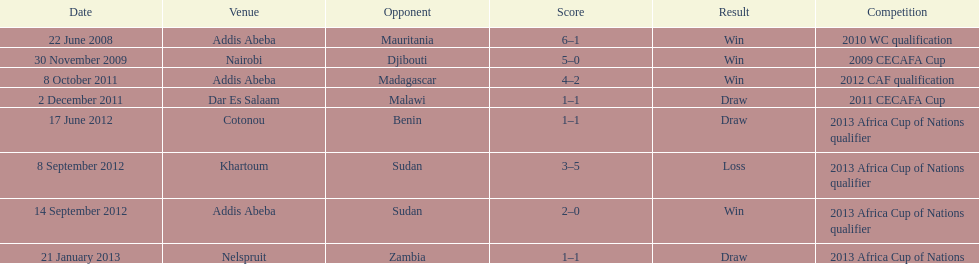True or false? in contrast, the ethiopian national team holds more draws than wins. False. 